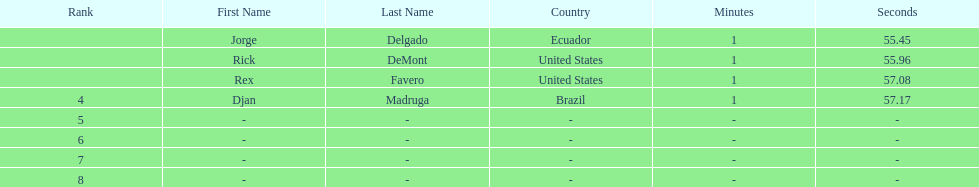Favero finished in 1:57.08. what was the next time? 1:57.17. 